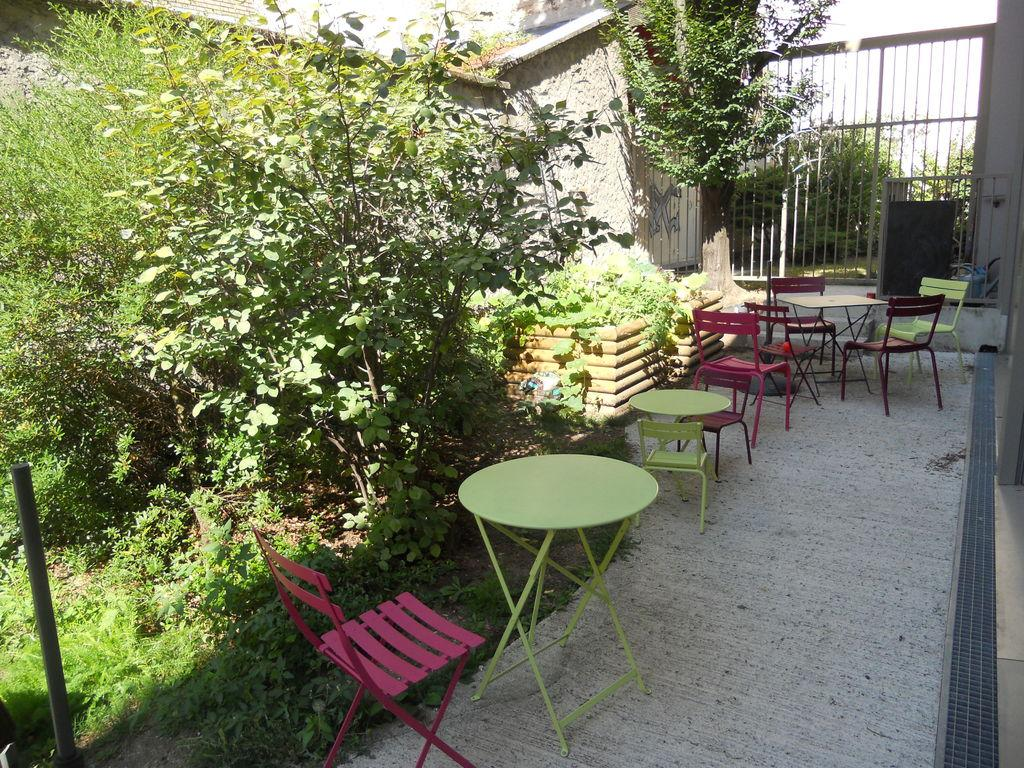What type of seating is available in the image? There are benches in the image, and chairs are around the benches. What other objects can be seen in the image? There are trees visible in the image. What structure is visible in the background of the image? There is a gate visible in the background of the image. How many cherries are hanging from the trees in the image? There are no cherries visible in the image; only trees are present. What is the size of the cent in the image? There is no cent present in the image. 